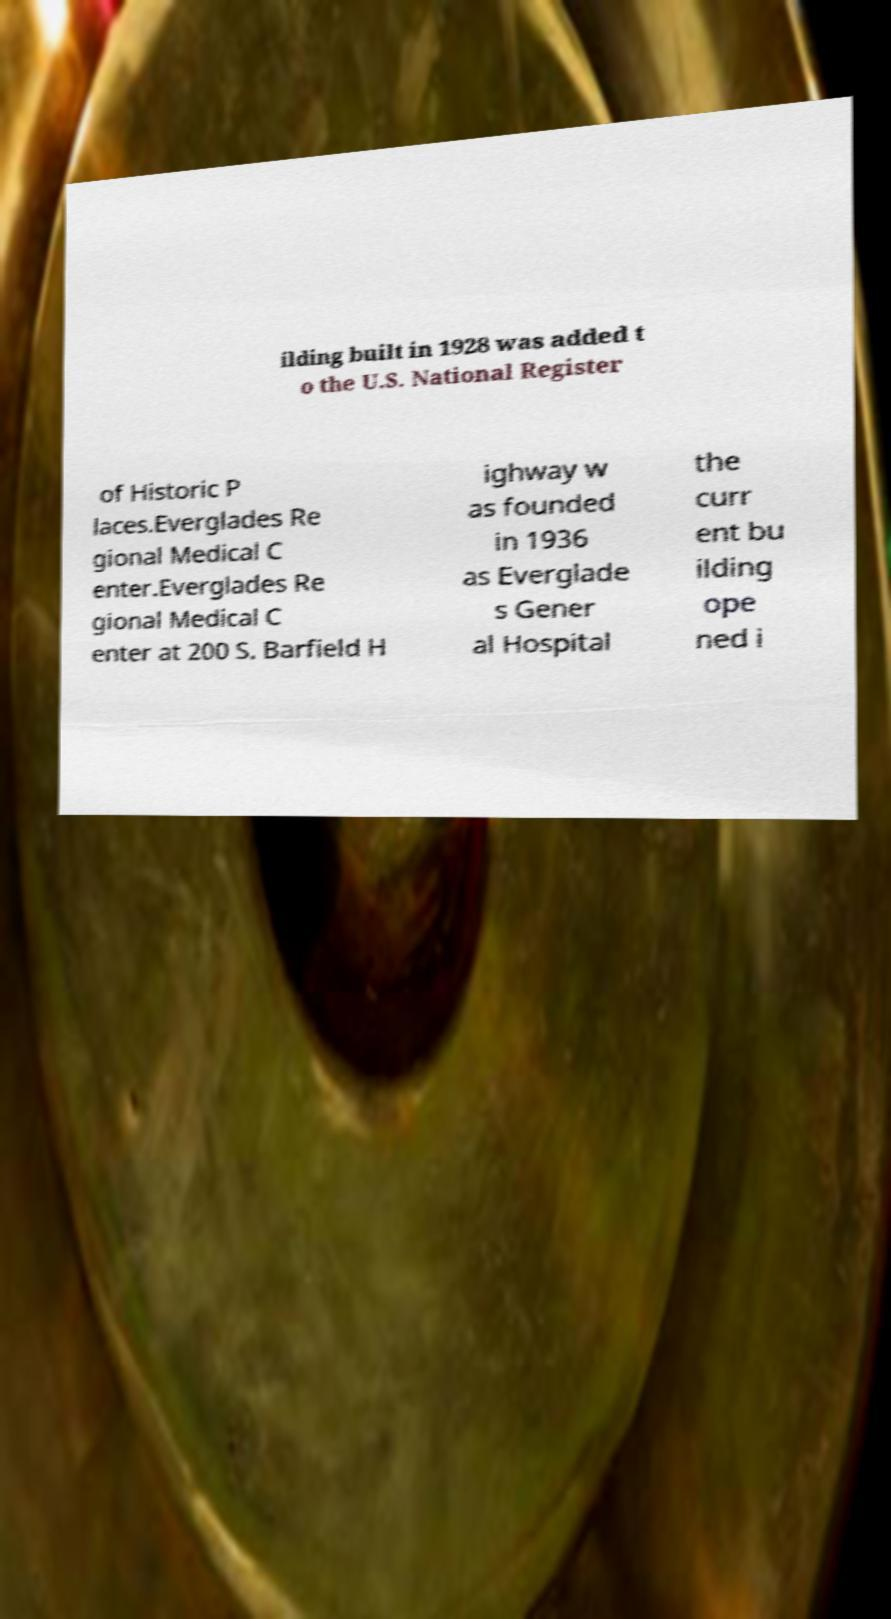Please read and relay the text visible in this image. What does it say? ilding built in 1928 was added t o the U.S. National Register of Historic P laces.Everglades Re gional Medical C enter.Everglades Re gional Medical C enter at 200 S. Barfield H ighway w as founded in 1936 as Everglade s Gener al Hospital the curr ent bu ilding ope ned i 